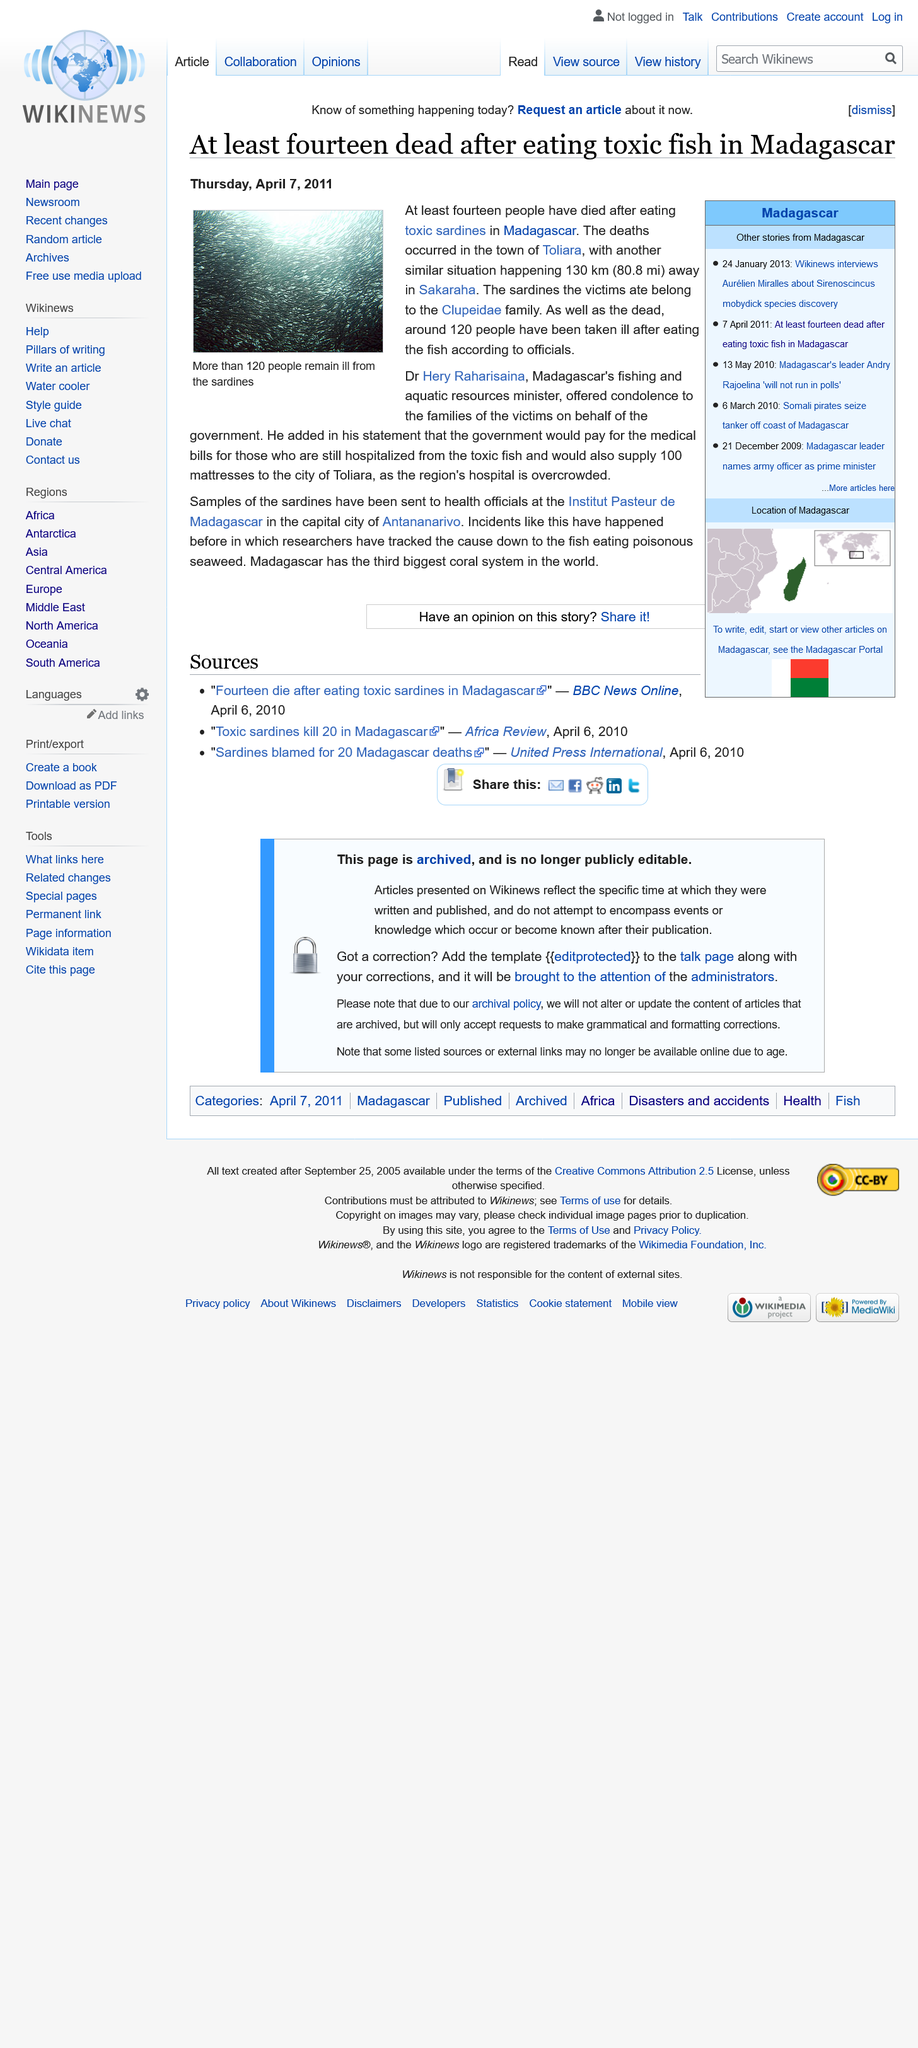List a handful of essential elements in this visual. Approximately 120 individuals fell ill. Fourteen people lost their lives in a country that remains unknown. It was announced that Dr Henry Raharisaina offered condolences on behalf of the government. 